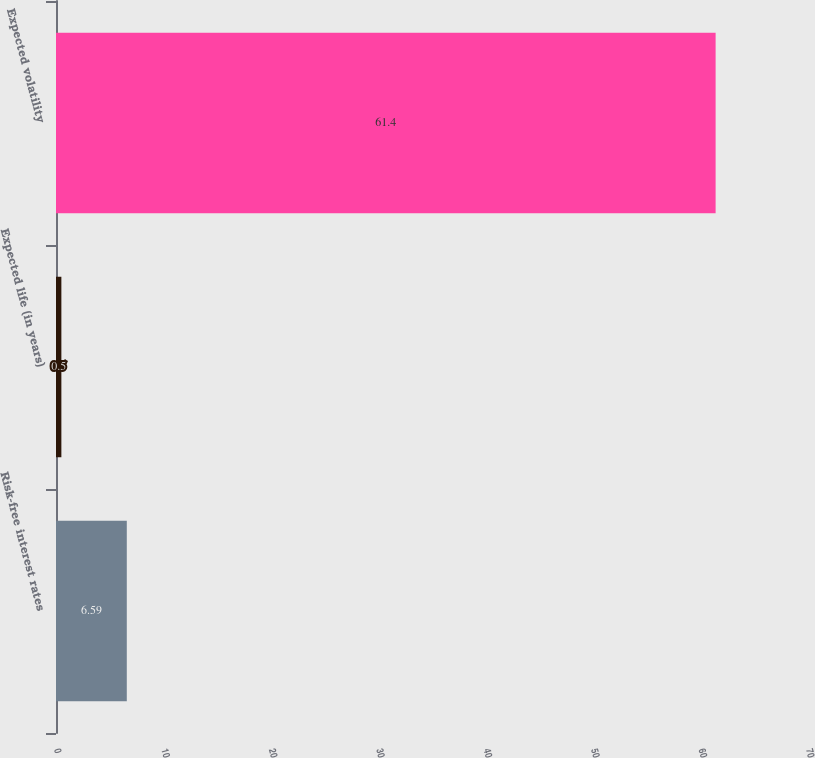Convert chart. <chart><loc_0><loc_0><loc_500><loc_500><bar_chart><fcel>Risk-free interest rates<fcel>Expected life (in years)<fcel>Expected volatility<nl><fcel>6.59<fcel>0.5<fcel>61.4<nl></chart> 